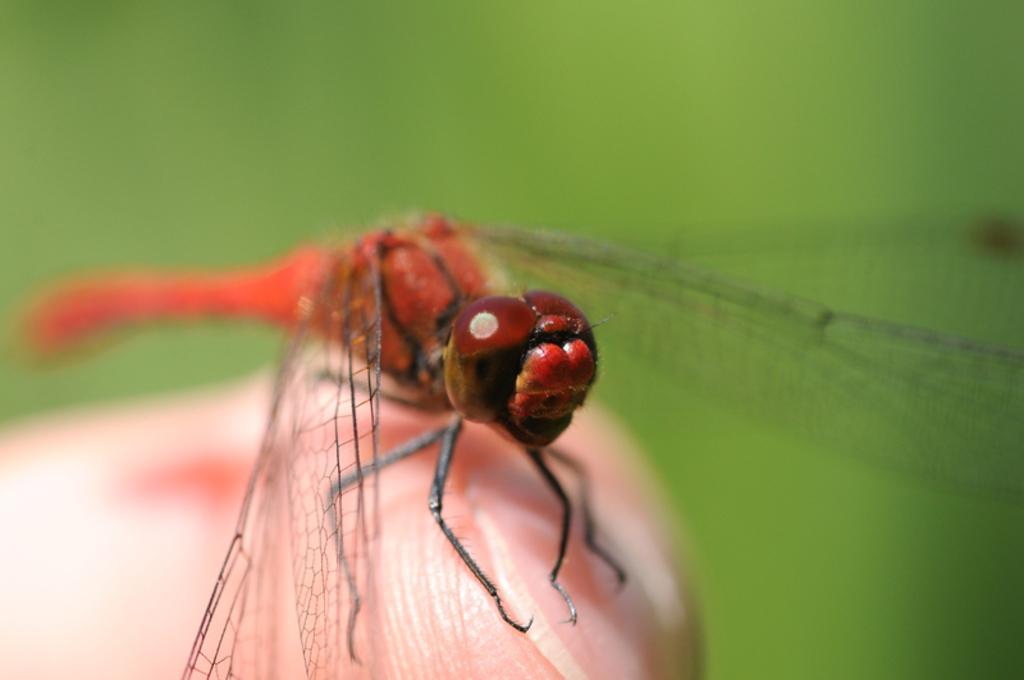Describe this image in one or two sentences. In this image we can see an insect on the finger of a person. 